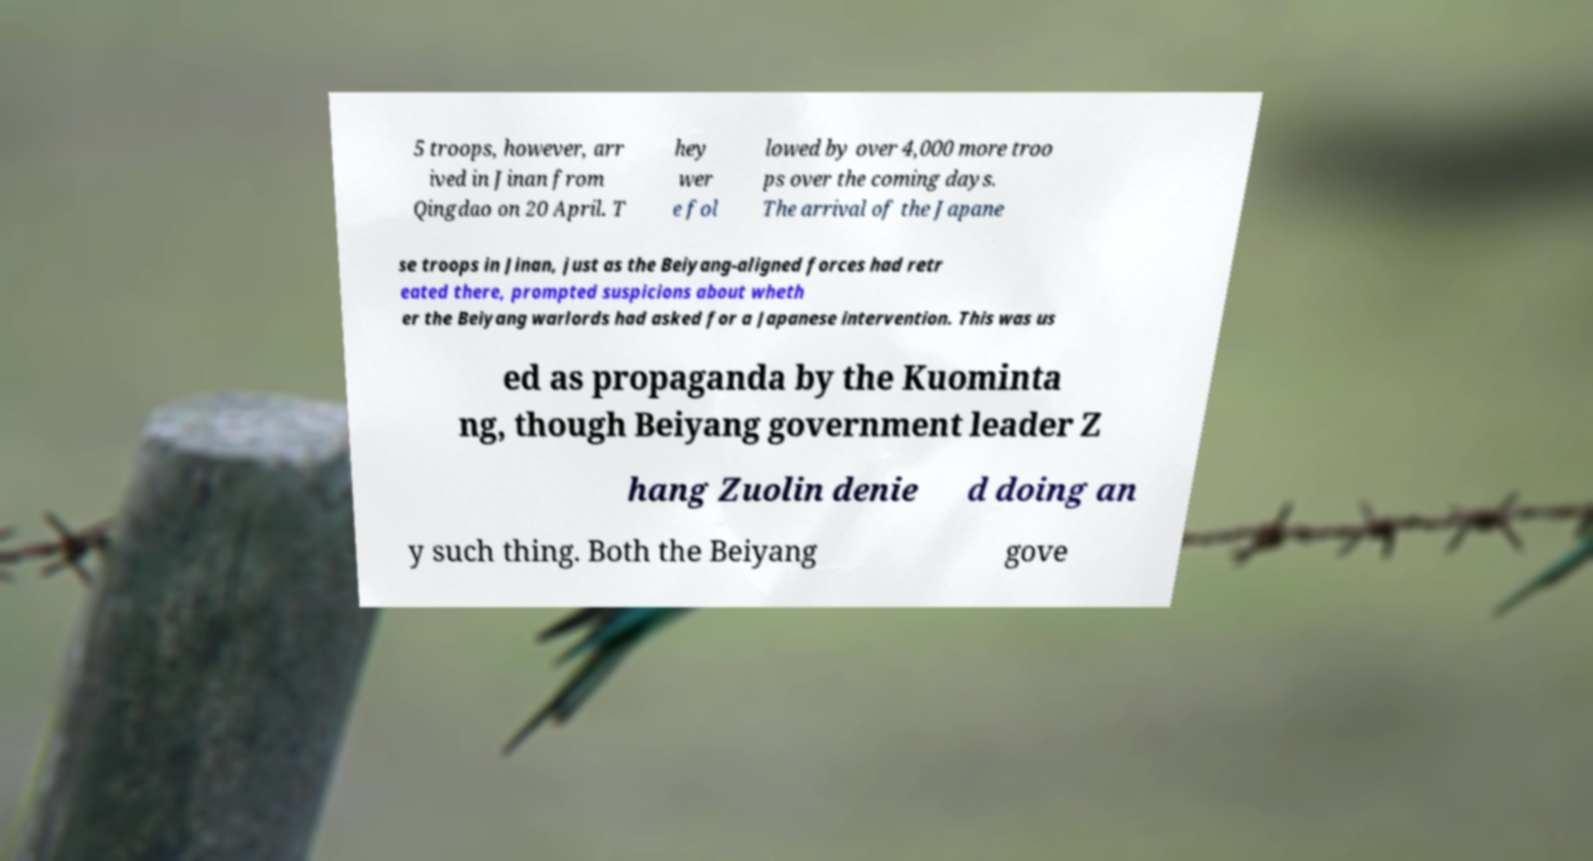What messages or text are displayed in this image? I need them in a readable, typed format. 5 troops, however, arr ived in Jinan from Qingdao on 20 April. T hey wer e fol lowed by over 4,000 more troo ps over the coming days. The arrival of the Japane se troops in Jinan, just as the Beiyang-aligned forces had retr eated there, prompted suspicions about wheth er the Beiyang warlords had asked for a Japanese intervention. This was us ed as propaganda by the Kuominta ng, though Beiyang government leader Z hang Zuolin denie d doing an y such thing. Both the Beiyang gove 